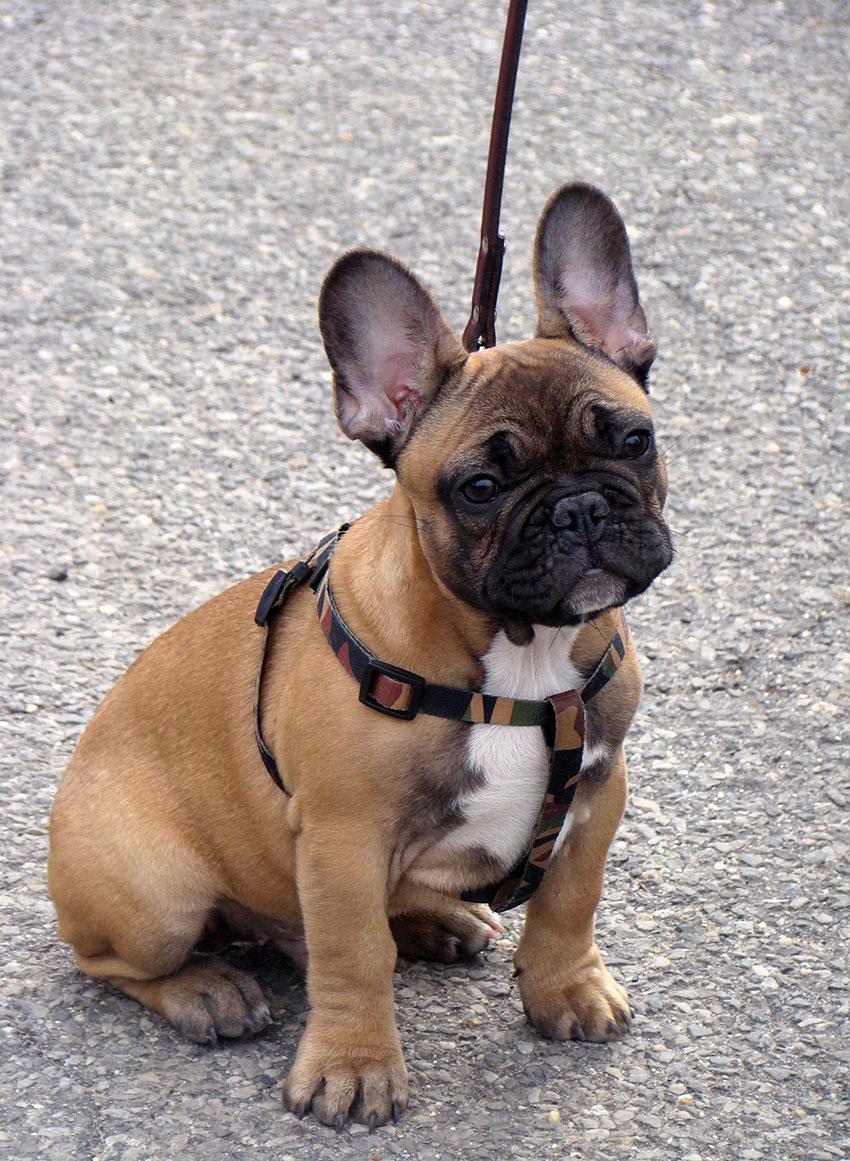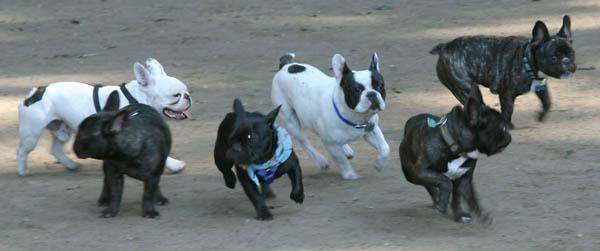The first image is the image on the left, the second image is the image on the right. For the images shown, is this caption "There is only one dog in one of the images." true? Answer yes or no. Yes. The first image is the image on the left, the second image is the image on the right. Assess this claim about the two images: "The left image contains no more than three dogs.". Correct or not? Answer yes or no. Yes. 